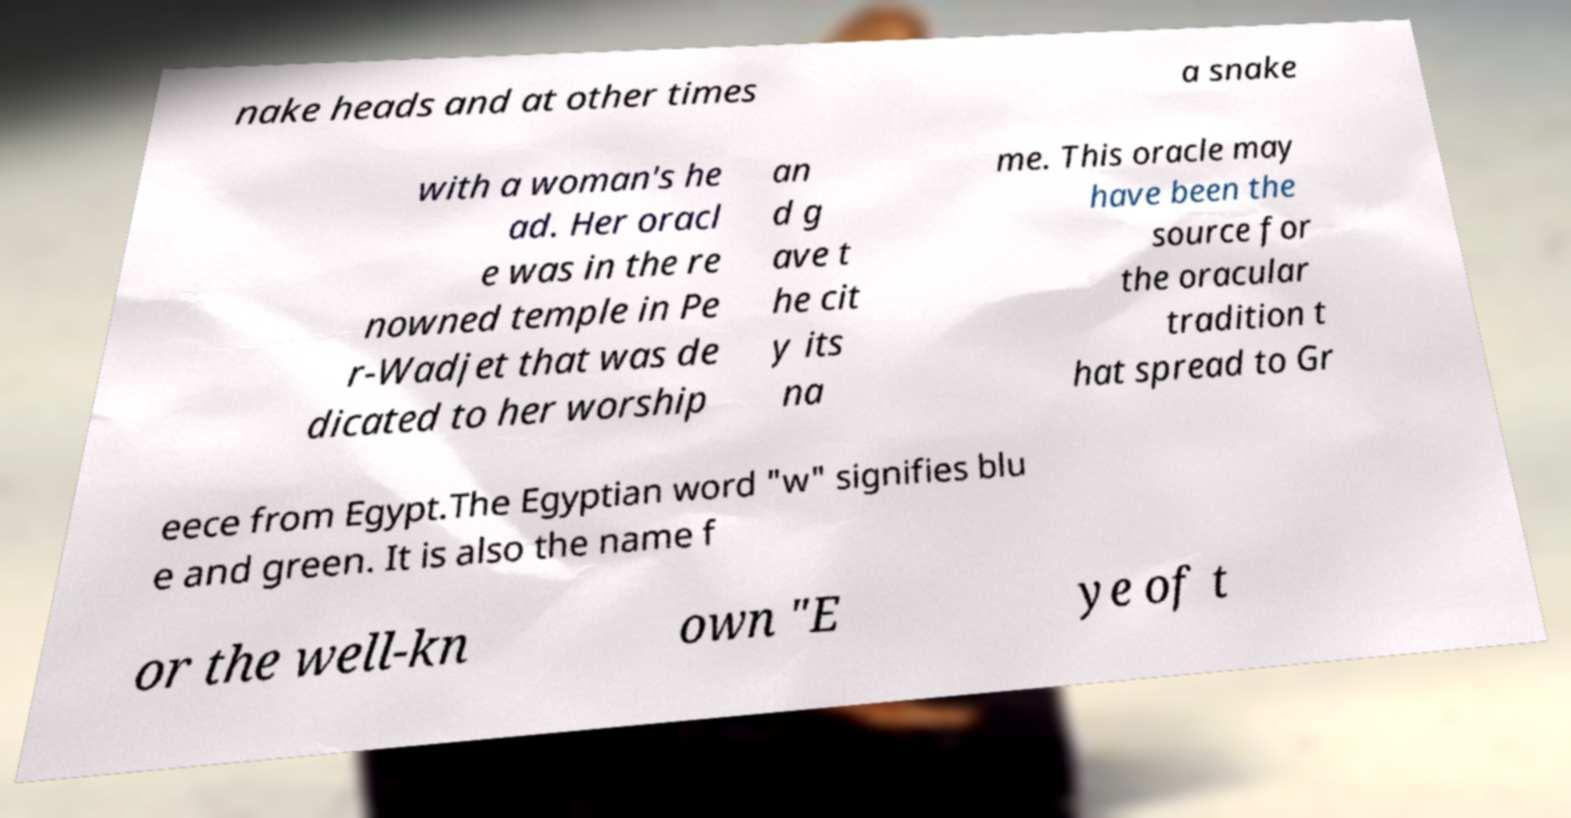What messages or text are displayed in this image? I need them in a readable, typed format. nake heads and at other times a snake with a woman's he ad. Her oracl e was in the re nowned temple in Pe r-Wadjet that was de dicated to her worship an d g ave t he cit y its na me. This oracle may have been the source for the oracular tradition t hat spread to Gr eece from Egypt.The Egyptian word "w" signifies blu e and green. It is also the name f or the well-kn own "E ye of t 